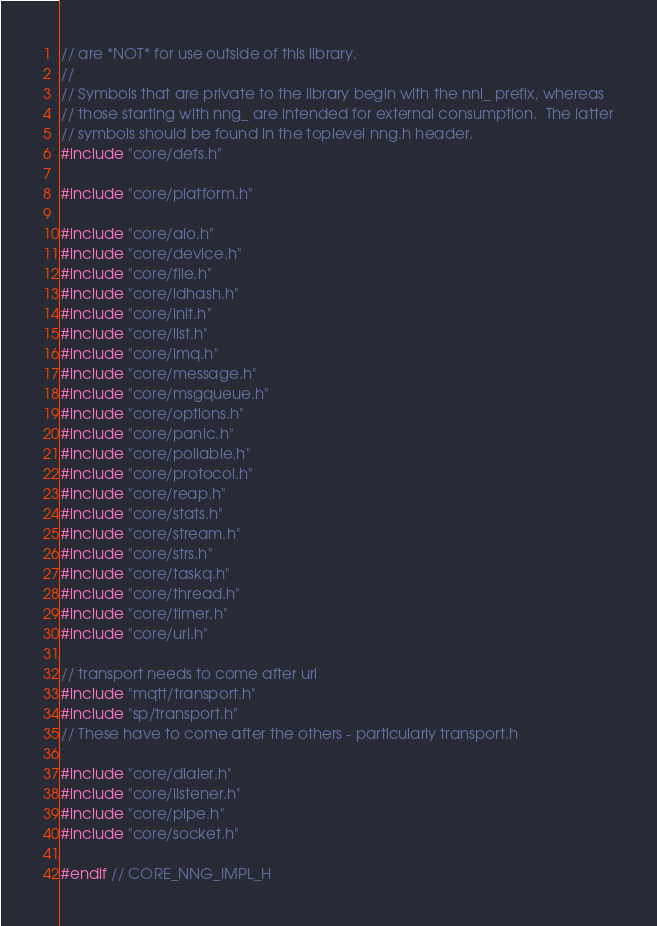Convert code to text. <code><loc_0><loc_0><loc_500><loc_500><_C_>// are *NOT* for use outside of this library.
//
// Symbols that are private to the library begin with the nni_ prefix, whereas
// those starting with nng_ are intended for external consumption.  The latter
// symbols should be found in the toplevel nng.h header.
#include "core/defs.h"

#include "core/platform.h"

#include "core/aio.h"
#include "core/device.h"
#include "core/file.h"
#include "core/idhash.h"
#include "core/init.h"
#include "core/list.h"
#include "core/lmq.h"
#include "core/message.h"
#include "core/msgqueue.h"
#include "core/options.h"
#include "core/panic.h"
#include "core/pollable.h"
#include "core/protocol.h"
#include "core/reap.h"
#include "core/stats.h"
#include "core/stream.h"
#include "core/strs.h"
#include "core/taskq.h"
#include "core/thread.h"
#include "core/timer.h"
#include "core/url.h"

// transport needs to come after url
#include "mqtt/transport.h"
#include "sp/transport.h"
// These have to come after the others - particularly transport.h

#include "core/dialer.h"
#include "core/listener.h"
#include "core/pipe.h"
#include "core/socket.h"

#endif // CORE_NNG_IMPL_H
</code> 